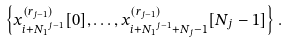<formula> <loc_0><loc_0><loc_500><loc_500>\left \{ x _ { i + { N _ { 1 } } ^ { j - 1 } } ^ { ( r _ { j - 1 } ) } [ 0 ] , \dots , x _ { i + { N _ { 1 } } ^ { j - 1 } + N _ { j } - 1 } ^ { ( r _ { j - 1 } ) } [ N _ { j } - 1 ] \right \} .</formula> 